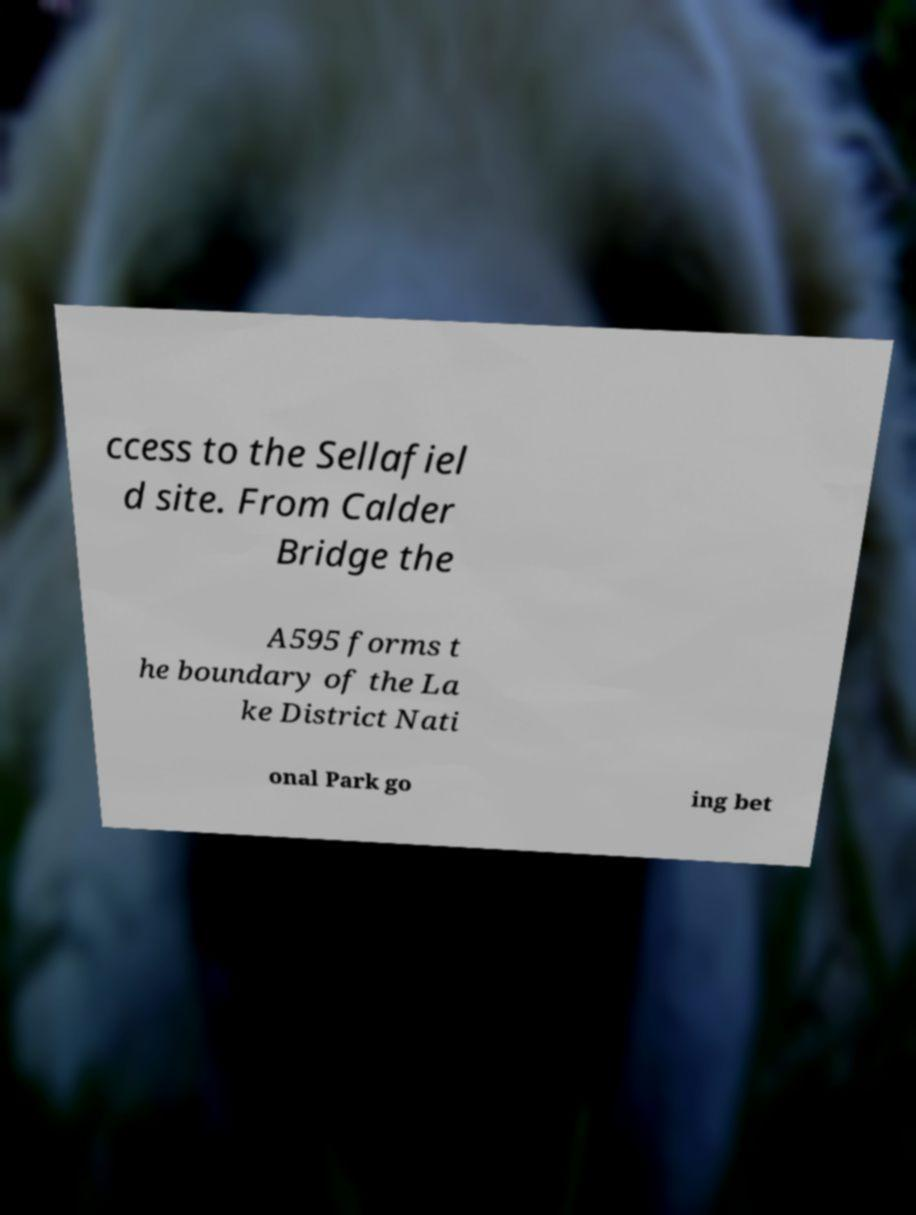What messages or text are displayed in this image? I need them in a readable, typed format. ccess to the Sellafiel d site. From Calder Bridge the A595 forms t he boundary of the La ke District Nati onal Park go ing bet 